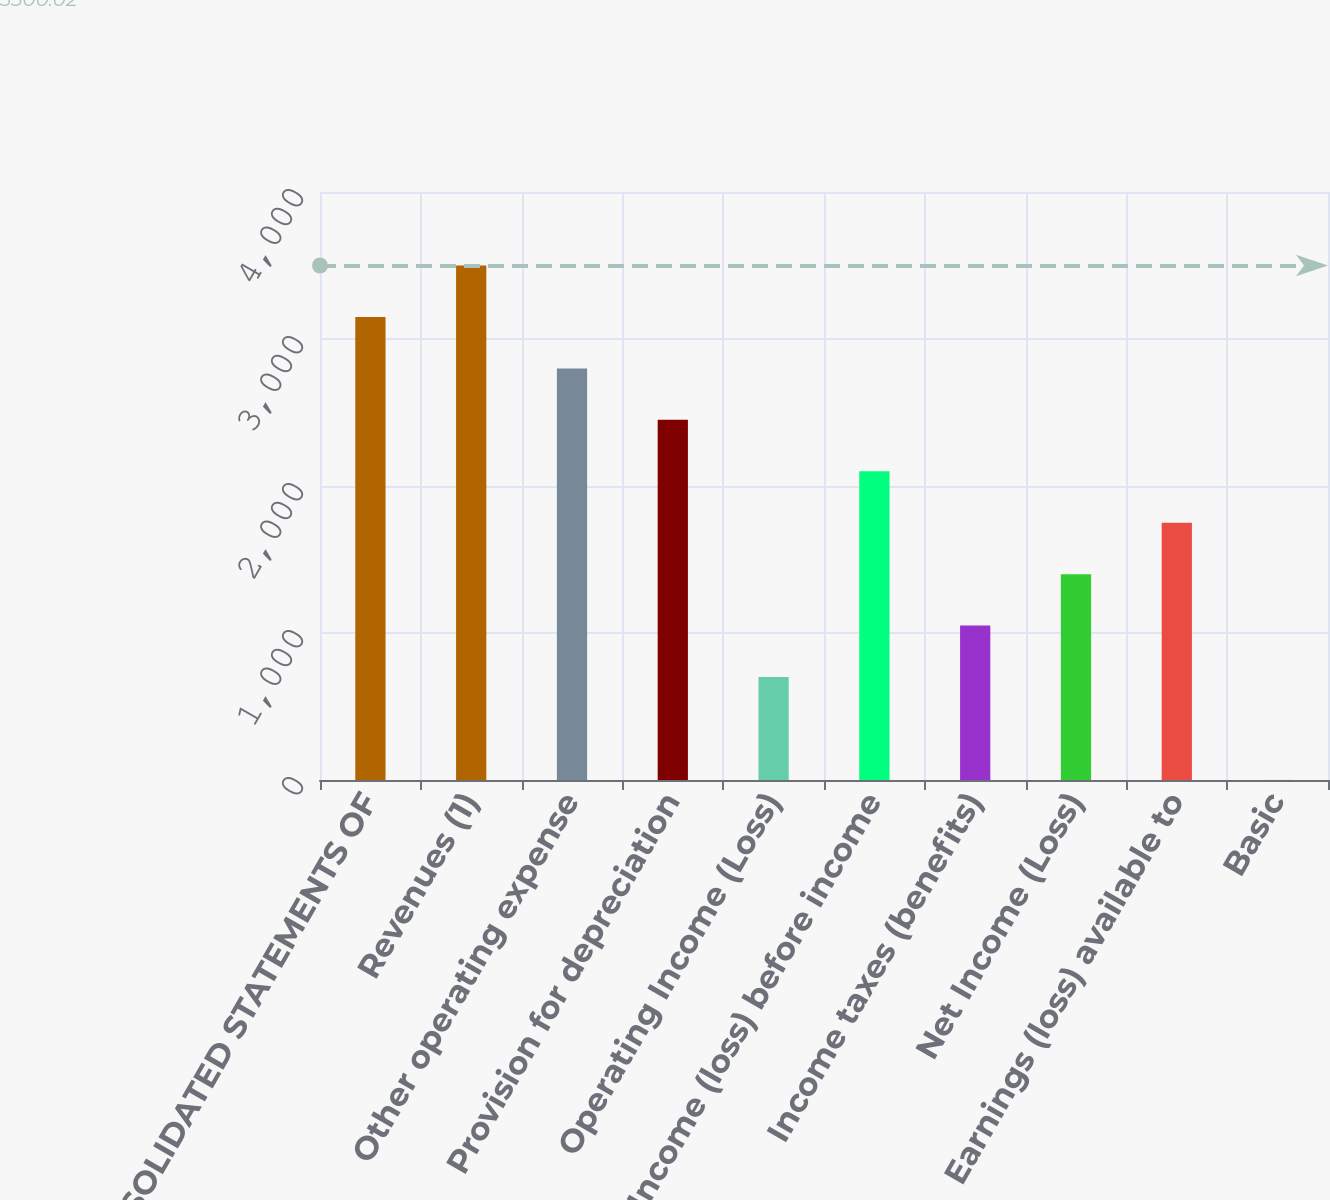Convert chart. <chart><loc_0><loc_0><loc_500><loc_500><bar_chart><fcel>CONSOLIDATED STATEMENTS OF<fcel>Revenues (1)<fcel>Other operating expense<fcel>Provision for depreciation<fcel>Operating Income (Loss)<fcel>Income (loss) before income<fcel>Income taxes (benefits)<fcel>Net Income (Loss)<fcel>Earnings (loss) available to<fcel>Basic<nl><fcel>3150.05<fcel>3500.02<fcel>2800.08<fcel>2450.11<fcel>700.29<fcel>2100.14<fcel>1050.26<fcel>1400.22<fcel>1750.18<fcel>0.35<nl></chart> 